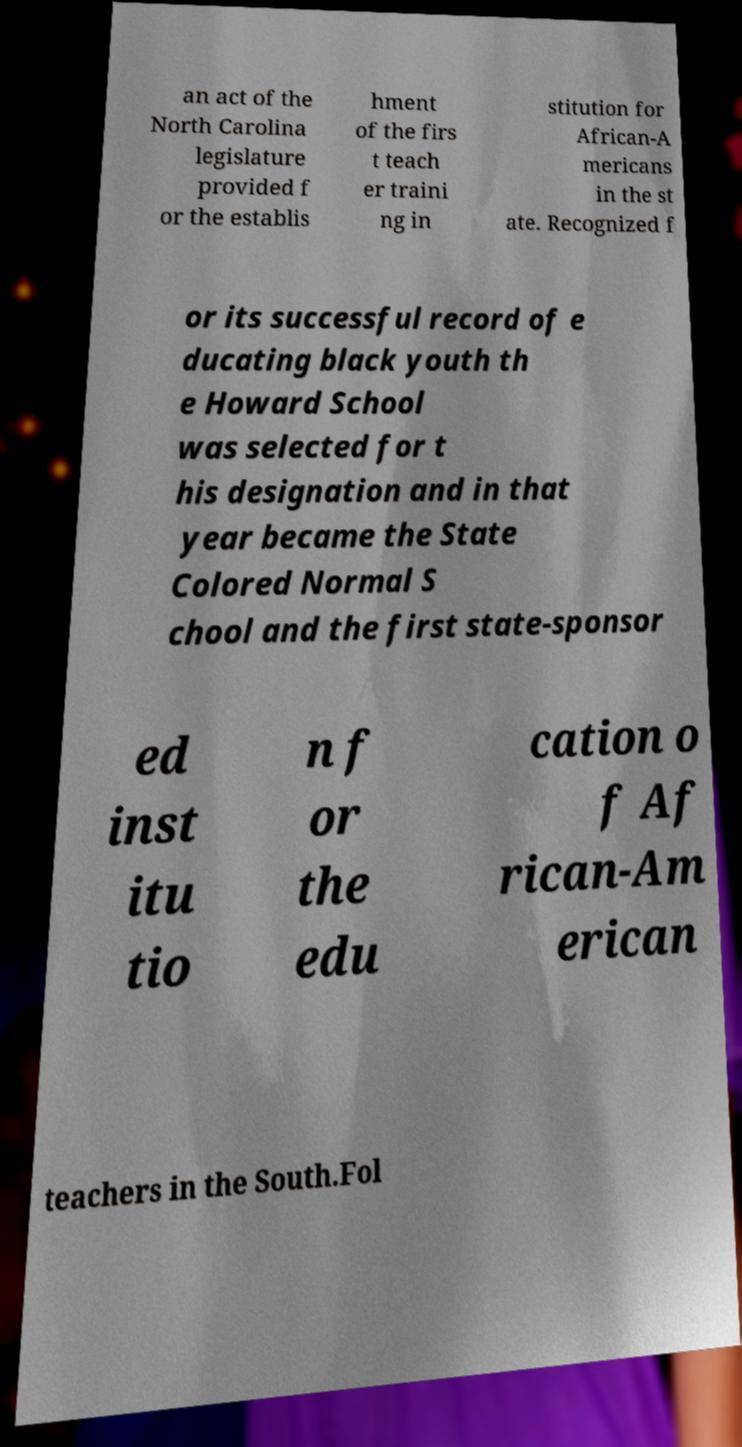Could you assist in decoding the text presented in this image and type it out clearly? an act of the North Carolina legislature provided f or the establis hment of the firs t teach er traini ng in stitution for African-A mericans in the st ate. Recognized f or its successful record of e ducating black youth th e Howard School was selected for t his designation and in that year became the State Colored Normal S chool and the first state-sponsor ed inst itu tio n f or the edu cation o f Af rican-Am erican teachers in the South.Fol 